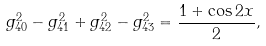<formula> <loc_0><loc_0><loc_500><loc_500>g _ { 4 0 } ^ { 2 } - g _ { 4 1 } ^ { 2 } + g _ { 4 2 } ^ { 2 } - g _ { 4 3 } ^ { 2 } = \frac { 1 + \cos 2 x } { 2 } ,</formula> 